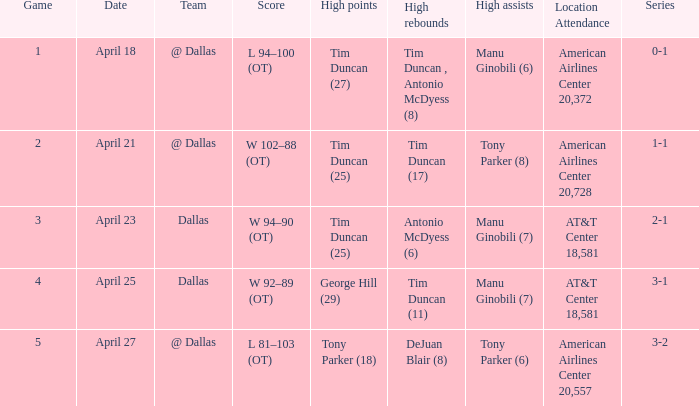In a game of 5, who has the most points accumulated? Tony Parker (18). 